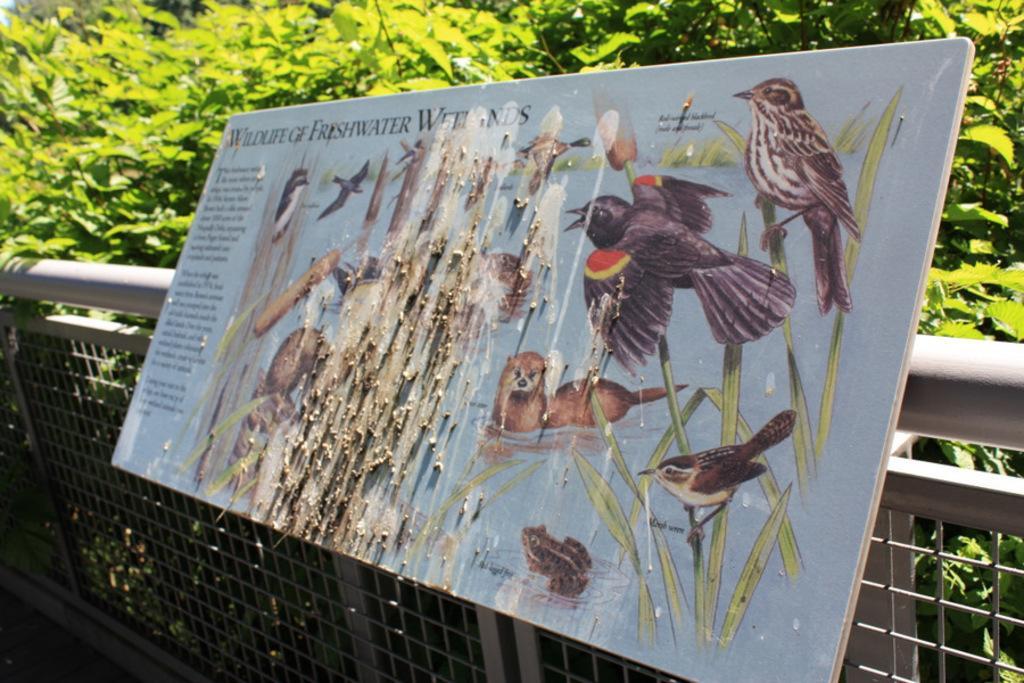In one or two sentences, can you explain what this image depicts? In this image I can see few trees and the fencing. I can see the board is attached to the fencing. 